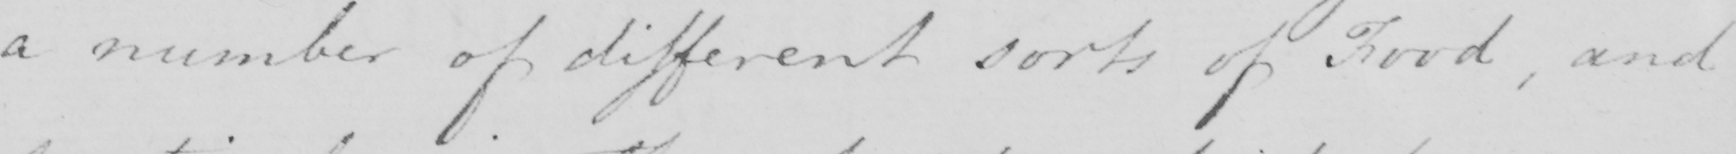What is written in this line of handwriting? a number of different sorts of food , and 